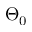<formula> <loc_0><loc_0><loc_500><loc_500>\Theta _ { 0 }</formula> 